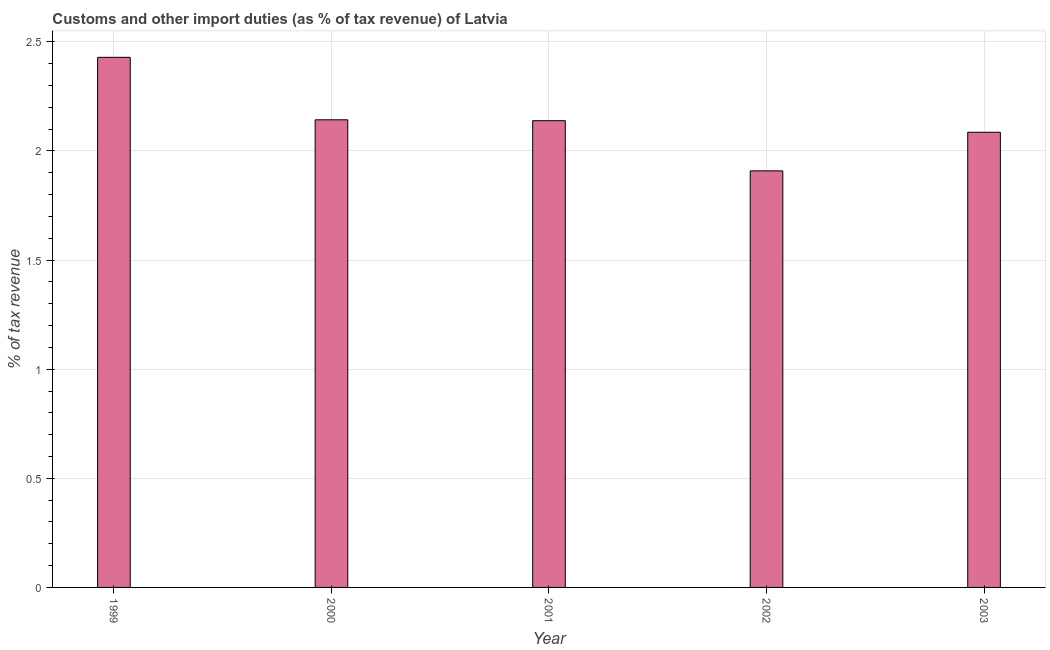What is the title of the graph?
Offer a terse response. Customs and other import duties (as % of tax revenue) of Latvia. What is the label or title of the Y-axis?
Your answer should be compact. % of tax revenue. What is the customs and other import duties in 2000?
Your answer should be compact. 2.14. Across all years, what is the maximum customs and other import duties?
Your response must be concise. 2.43. Across all years, what is the minimum customs and other import duties?
Keep it short and to the point. 1.91. In which year was the customs and other import duties minimum?
Your answer should be very brief. 2002. What is the sum of the customs and other import duties?
Your answer should be very brief. 10.7. What is the difference between the customs and other import duties in 2000 and 2002?
Provide a succinct answer. 0.23. What is the average customs and other import duties per year?
Offer a terse response. 2.14. What is the median customs and other import duties?
Keep it short and to the point. 2.14. In how many years, is the customs and other import duties greater than 1.3 %?
Provide a short and direct response. 5. What is the ratio of the customs and other import duties in 2002 to that in 2003?
Give a very brief answer. 0.92. Is the difference between the customs and other import duties in 2001 and 2003 greater than the difference between any two years?
Your answer should be very brief. No. What is the difference between the highest and the second highest customs and other import duties?
Your answer should be compact. 0.29. Is the sum of the customs and other import duties in 2000 and 2002 greater than the maximum customs and other import duties across all years?
Provide a short and direct response. Yes. What is the difference between the highest and the lowest customs and other import duties?
Your answer should be very brief. 0.52. How many bars are there?
Provide a short and direct response. 5. Are all the bars in the graph horizontal?
Ensure brevity in your answer.  No. What is the % of tax revenue of 1999?
Provide a succinct answer. 2.43. What is the % of tax revenue of 2000?
Keep it short and to the point. 2.14. What is the % of tax revenue in 2001?
Ensure brevity in your answer.  2.14. What is the % of tax revenue of 2002?
Your answer should be very brief. 1.91. What is the % of tax revenue of 2003?
Offer a terse response. 2.09. What is the difference between the % of tax revenue in 1999 and 2000?
Ensure brevity in your answer.  0.29. What is the difference between the % of tax revenue in 1999 and 2001?
Make the answer very short. 0.29. What is the difference between the % of tax revenue in 1999 and 2002?
Provide a succinct answer. 0.52. What is the difference between the % of tax revenue in 1999 and 2003?
Provide a short and direct response. 0.34. What is the difference between the % of tax revenue in 2000 and 2001?
Your answer should be compact. 0. What is the difference between the % of tax revenue in 2000 and 2002?
Ensure brevity in your answer.  0.23. What is the difference between the % of tax revenue in 2000 and 2003?
Make the answer very short. 0.06. What is the difference between the % of tax revenue in 2001 and 2002?
Your response must be concise. 0.23. What is the difference between the % of tax revenue in 2001 and 2003?
Make the answer very short. 0.05. What is the difference between the % of tax revenue in 2002 and 2003?
Offer a very short reply. -0.18. What is the ratio of the % of tax revenue in 1999 to that in 2000?
Ensure brevity in your answer.  1.13. What is the ratio of the % of tax revenue in 1999 to that in 2001?
Your response must be concise. 1.14. What is the ratio of the % of tax revenue in 1999 to that in 2002?
Offer a terse response. 1.27. What is the ratio of the % of tax revenue in 1999 to that in 2003?
Your answer should be compact. 1.17. What is the ratio of the % of tax revenue in 2000 to that in 2002?
Offer a terse response. 1.12. What is the ratio of the % of tax revenue in 2001 to that in 2002?
Ensure brevity in your answer.  1.12. What is the ratio of the % of tax revenue in 2002 to that in 2003?
Offer a terse response. 0.92. 